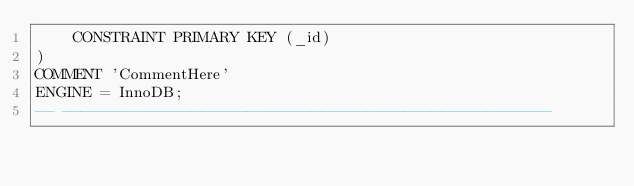Convert code to text. <code><loc_0><loc_0><loc_500><loc_500><_SQL_>	CONSTRAINT PRIMARY KEY (_id)
)
COMMENT 'CommentHere'
ENGINE = InnoDB;
-- -----------------------------------------------------
</code> 